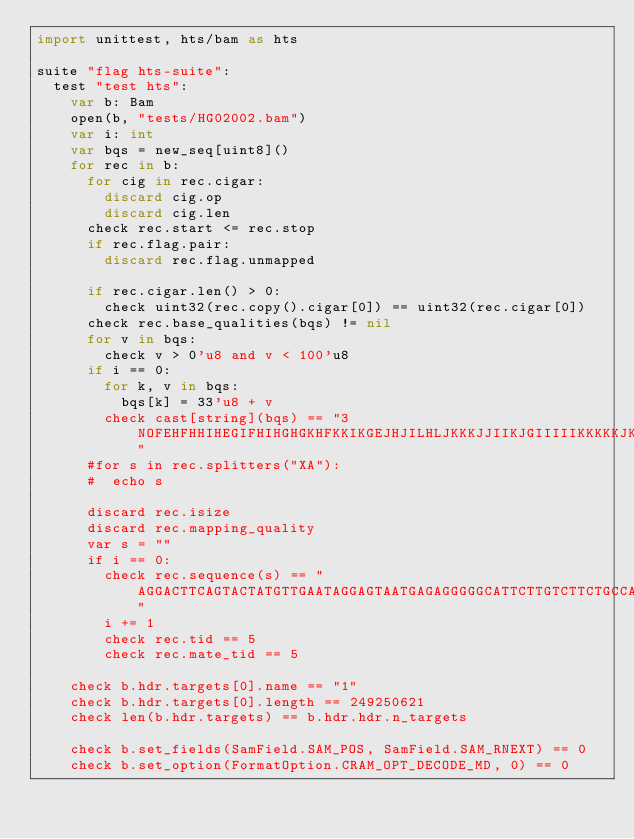<code> <loc_0><loc_0><loc_500><loc_500><_Nim_>import unittest, hts/bam as hts

suite "flag hts-suite":
  test "test hts":
    var b: Bam
    open(b, "tests/HG02002.bam")
    var i: int
    var bqs = new_seq[uint8]()
    for rec in b:
      for cig in rec.cigar:
        discard cig.op
        discard cig.len
      check rec.start <= rec.stop
      if rec.flag.pair:
        discard rec.flag.unmapped

      if rec.cigar.len() > 0:
        check uint32(rec.copy().cigar[0]) == uint32(rec.cigar[0])
      check rec.base_qualities(bqs) != nil
      for v in bqs:
        check v > 0'u8 and v < 100'u8
      if i == 0:
        for k, v in bqs:
          bqs[k] = 33'u8 + v
        check cast[string](bqs) == "3NOFEHFHHIHEGIFHIHGHGKHFKKIKGEJHJILHLJKKKJJIIKJGIIIIIKKKKKJKGGFFJIMKKGJGEGONOCIJIIJJCCCJJHJIHCHIGFBED"
      #for s in rec.splitters("XA"):
      #  echo s

      discard rec.isize
      discard rec.mapping_quality
      var s = ""
      if i == 0:
        check rec.sequence(s) == "AGGACTTCAGTACTATGTTGAATAGGAGTAATGAGAGGGGGCATTCTTGTCTTCTGCCAGTTTTCAAGGGGAATGCTTCCAGCTTTTGCCCATTCAGTATG"
        i += 1
        check rec.tid == 5
        check rec.mate_tid == 5

    check b.hdr.targets[0].name == "1"
    check b.hdr.targets[0].length == 249250621
    check len(b.hdr.targets) == b.hdr.hdr.n_targets

    check b.set_fields(SamField.SAM_POS, SamField.SAM_RNEXT) == 0
    check b.set_option(FormatOption.CRAM_OPT_DECODE_MD, 0) == 0


</code> 